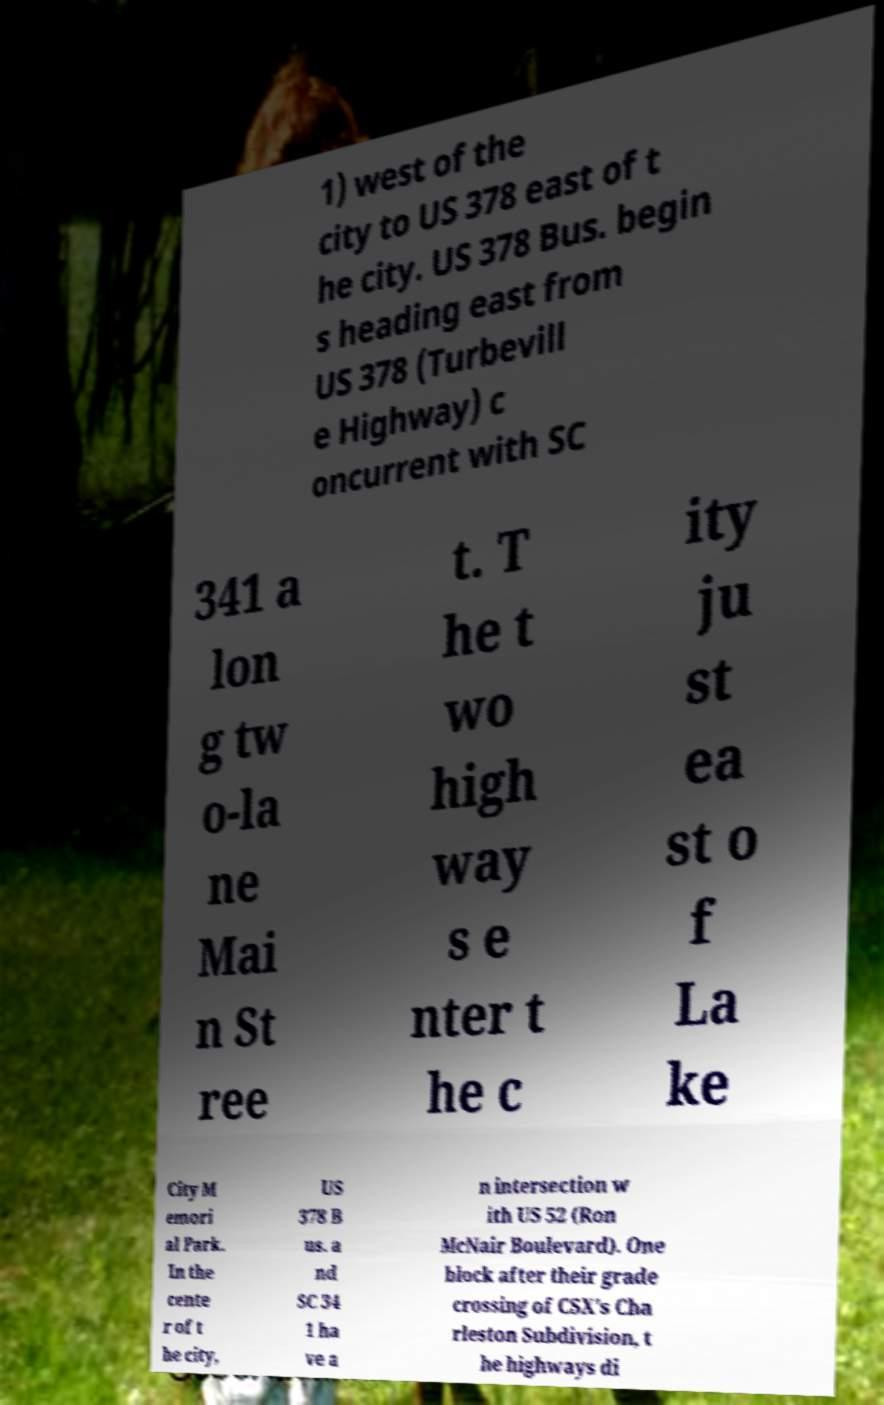What messages or text are displayed in this image? I need them in a readable, typed format. 1) west of the city to US 378 east of t he city. US 378 Bus. begin s heading east from US 378 (Turbevill e Highway) c oncurrent with SC 341 a lon g tw o-la ne Mai n St ree t. T he t wo high way s e nter t he c ity ju st ea st o f La ke City M emori al Park. In the cente r of t he city, US 378 B us. a nd SC 34 1 ha ve a n intersection w ith US 52 (Ron McNair Boulevard). One block after their grade crossing of CSX's Cha rleston Subdivision, t he highways di 